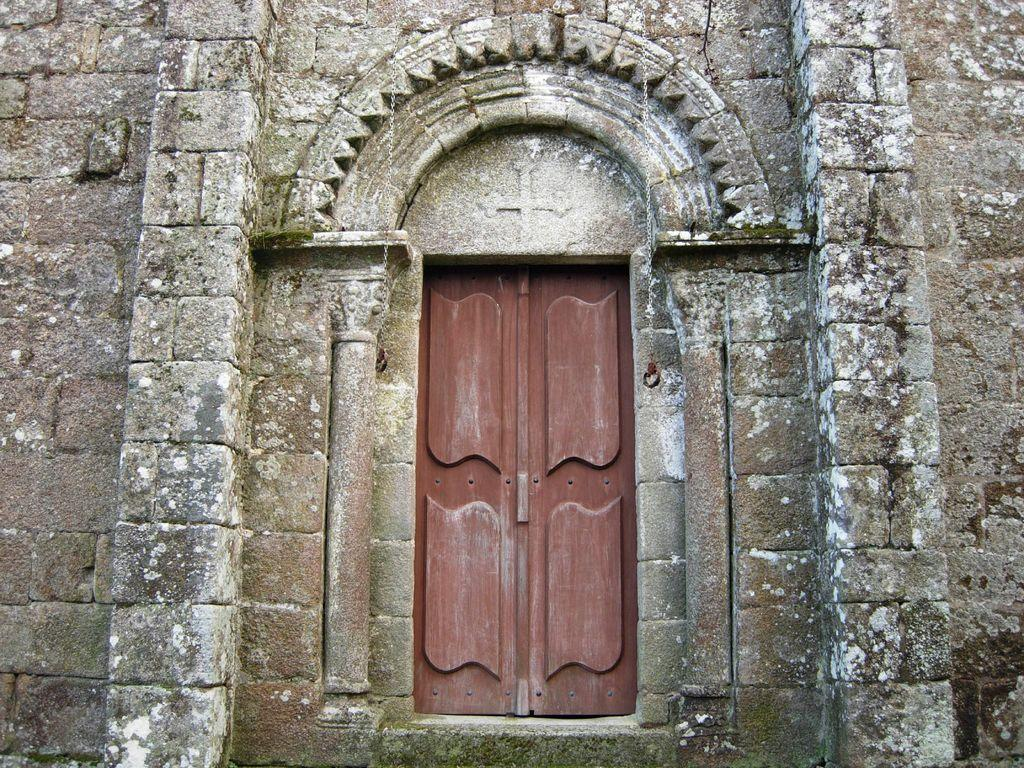What is the main architectural feature in the image? There is a door in the image. Where is the door situated? The door is located between two walls. What design element is present above the door? There is an arch above the door. What type of drawer can be seen hanging from the chin of the person in the image? There is no person or drawer present in the image; it only features a door between two walls with an arch above it. 